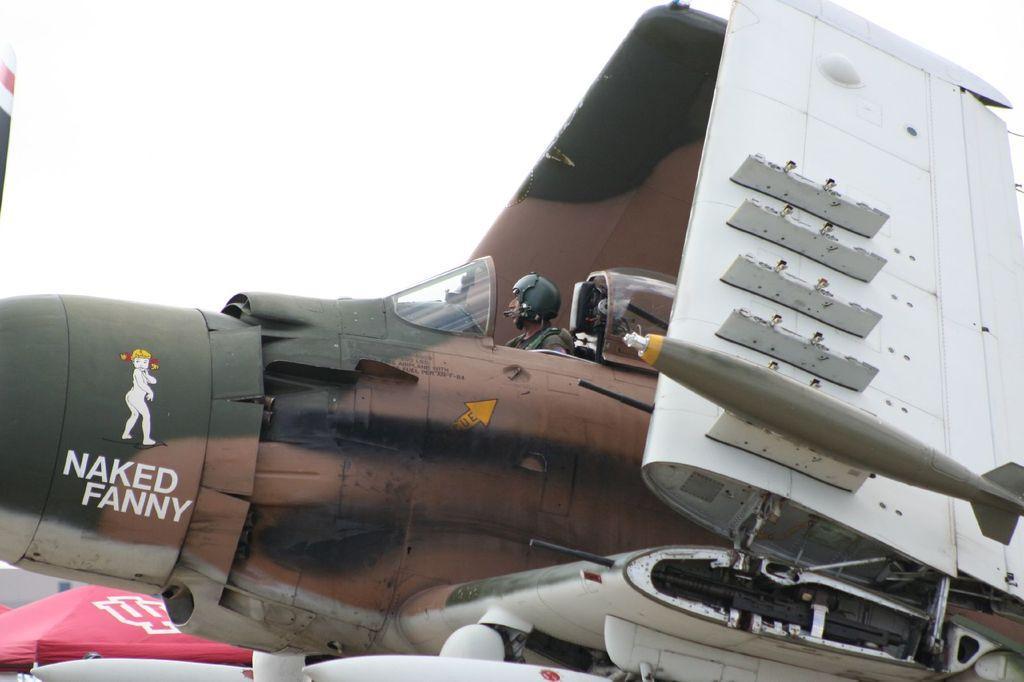Can you describe this image briefly? In the middle of the picture, we see the man riding the airplane. It is in black, brown and white color. In the left bottom, we see a tent in red color. In the background, we see the sky. 